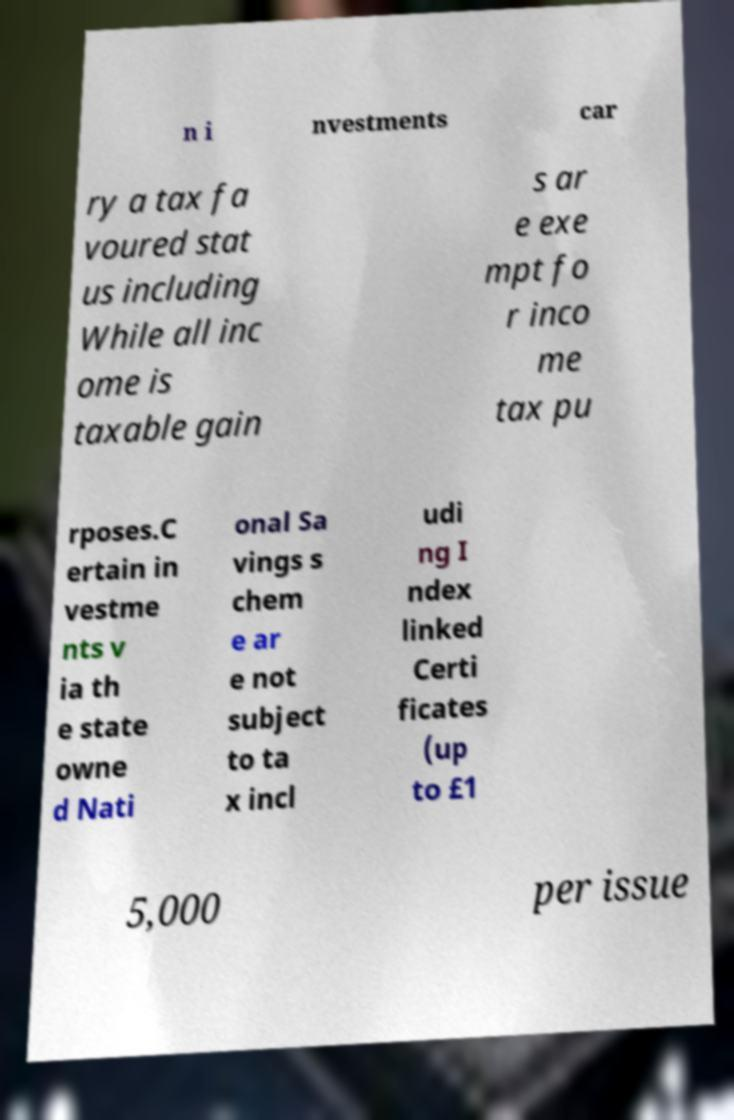Could you extract and type out the text from this image? n i nvestments car ry a tax fa voured stat us including While all inc ome is taxable gain s ar e exe mpt fo r inco me tax pu rposes.C ertain in vestme nts v ia th e state owne d Nati onal Sa vings s chem e ar e not subject to ta x incl udi ng I ndex linked Certi ficates (up to £1 5,000 per issue 